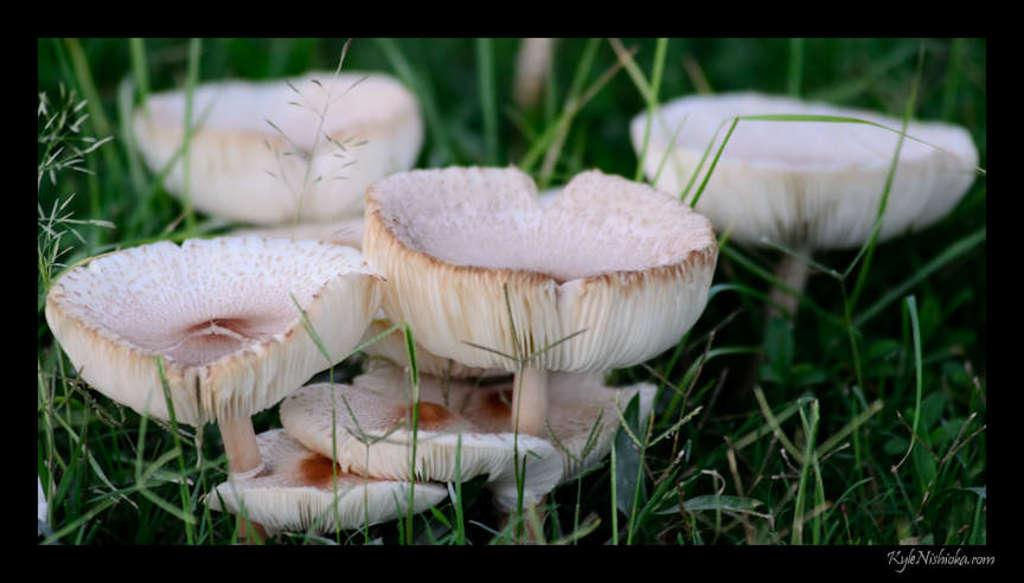What type of vegetation is present in the image? The image contains mushrooms and grass. What is the color of the border surrounding the image? The image has a black border. How many girls are participating in the event depicted in the image? There is no event or girls present in the image; it contains mushrooms and grass with a black border. 